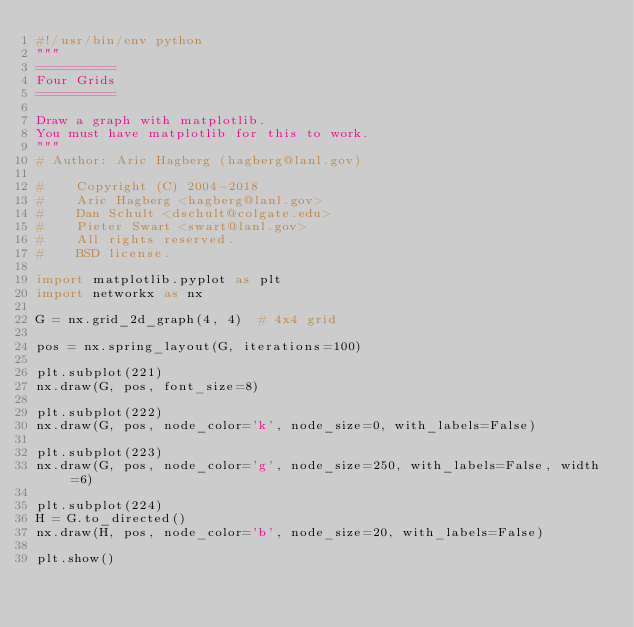<code> <loc_0><loc_0><loc_500><loc_500><_Python_>#!/usr/bin/env python
"""
==========
Four Grids
==========

Draw a graph with matplotlib.
You must have matplotlib for this to work.
"""
# Author: Aric Hagberg (hagberg@lanl.gov)

#    Copyright (C) 2004-2018
#    Aric Hagberg <hagberg@lanl.gov>
#    Dan Schult <dschult@colgate.edu>
#    Pieter Swart <swart@lanl.gov>
#    All rights reserved.
#    BSD license.

import matplotlib.pyplot as plt
import networkx as nx

G = nx.grid_2d_graph(4, 4)  # 4x4 grid

pos = nx.spring_layout(G, iterations=100)

plt.subplot(221)
nx.draw(G, pos, font_size=8)

plt.subplot(222)
nx.draw(G, pos, node_color='k', node_size=0, with_labels=False)

plt.subplot(223)
nx.draw(G, pos, node_color='g', node_size=250, with_labels=False, width=6)

plt.subplot(224)
H = G.to_directed()
nx.draw(H, pos, node_color='b', node_size=20, with_labels=False)

plt.show()
</code> 